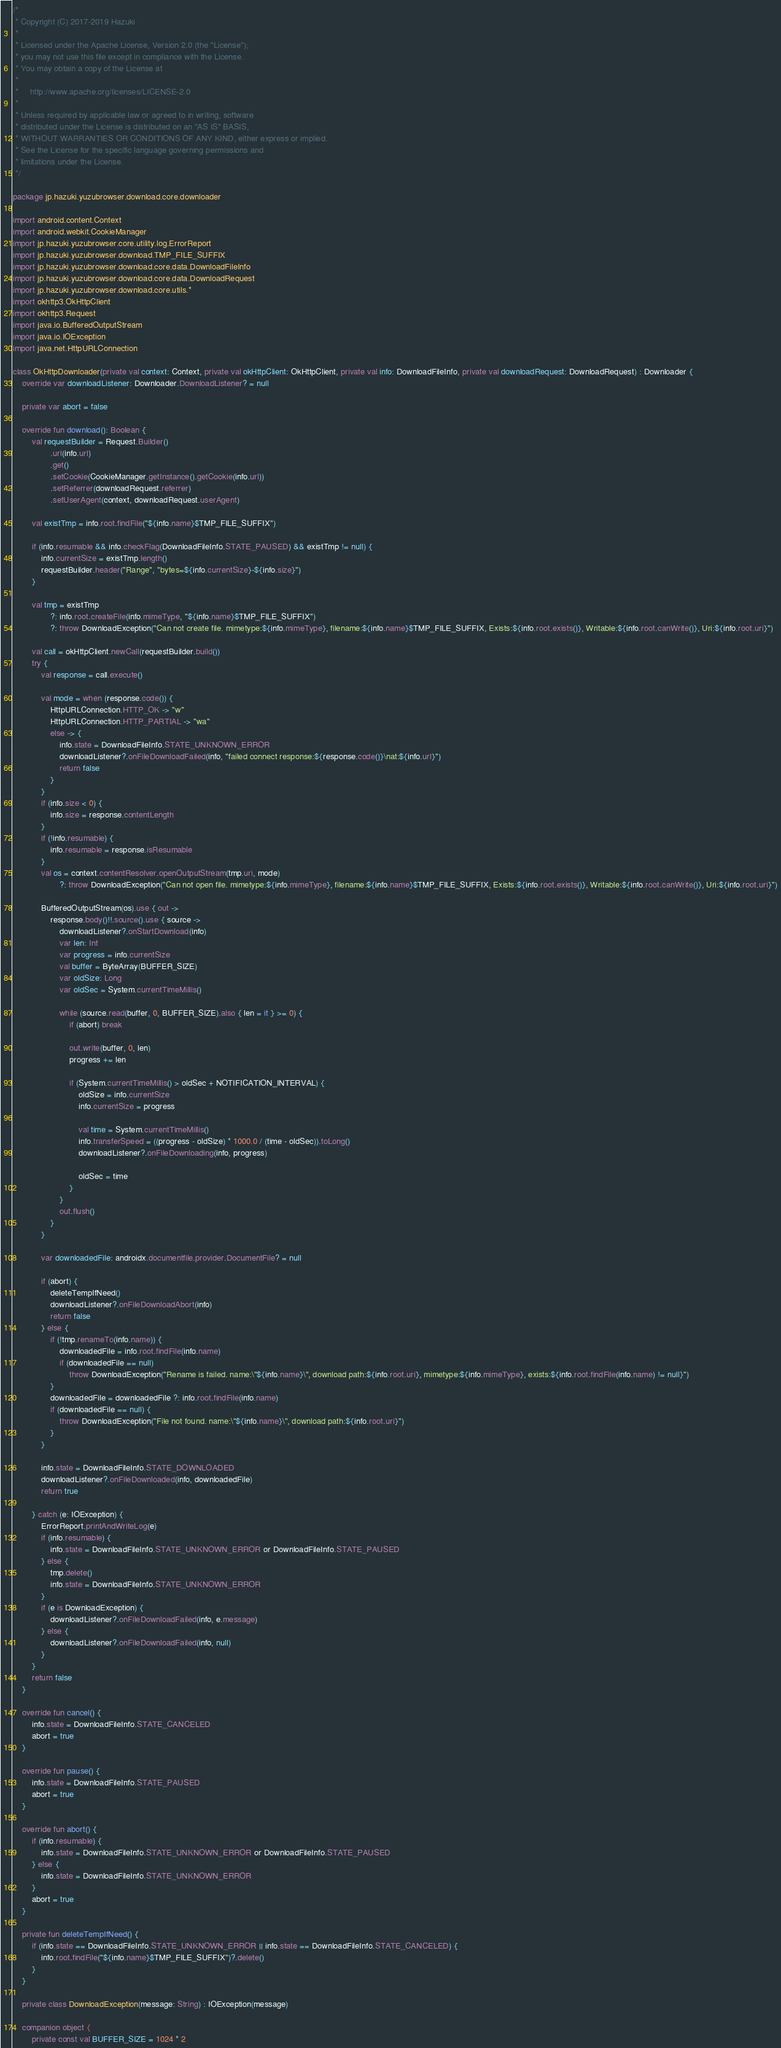Convert code to text. <code><loc_0><loc_0><loc_500><loc_500><_Kotlin_>/*
 * Copyright (C) 2017-2019 Hazuki
 *
 * Licensed under the Apache License, Version 2.0 (the "License");
 * you may not use this file except in compliance with the License.
 * You may obtain a copy of the License at
 *
 *     http://www.apache.org/licenses/LICENSE-2.0
 *
 * Unless required by applicable law or agreed to in writing, software
 * distributed under the License is distributed on an "AS IS" BASIS,
 * WITHOUT WARRANTIES OR CONDITIONS OF ANY KIND, either express or implied.
 * See the License for the specific language governing permissions and
 * limitations under the License.
 */

package jp.hazuki.yuzubrowser.download.core.downloader

import android.content.Context
import android.webkit.CookieManager
import jp.hazuki.yuzubrowser.core.utility.log.ErrorReport
import jp.hazuki.yuzubrowser.download.TMP_FILE_SUFFIX
import jp.hazuki.yuzubrowser.download.core.data.DownloadFileInfo
import jp.hazuki.yuzubrowser.download.core.data.DownloadRequest
import jp.hazuki.yuzubrowser.download.core.utils.*
import okhttp3.OkHttpClient
import okhttp3.Request
import java.io.BufferedOutputStream
import java.io.IOException
import java.net.HttpURLConnection

class OkHttpDownloader(private val context: Context, private val okHttpClient: OkHttpClient, private val info: DownloadFileInfo, private val downloadRequest: DownloadRequest) : Downloader {
    override var downloadListener: Downloader.DownloadListener? = null

    private var abort = false

    override fun download(): Boolean {
        val requestBuilder = Request.Builder()
                .url(info.url)
                .get()
                .setCookie(CookieManager.getInstance().getCookie(info.url))
                .setReferrer(downloadRequest.referrer)
                .setUserAgent(context, downloadRequest.userAgent)

        val existTmp = info.root.findFile("${info.name}$TMP_FILE_SUFFIX")

        if (info.resumable && info.checkFlag(DownloadFileInfo.STATE_PAUSED) && existTmp != null) {
            info.currentSize = existTmp.length()
            requestBuilder.header("Range", "bytes=${info.currentSize}-${info.size}")
        }

        val tmp = existTmp
                ?: info.root.createFile(info.mimeType, "${info.name}$TMP_FILE_SUFFIX")
                ?: throw DownloadException("Can not create file. mimetype:${info.mimeType}, filename:${info.name}$TMP_FILE_SUFFIX, Exists:${info.root.exists()}, Writable:${info.root.canWrite()}, Uri:${info.root.uri}")

        val call = okHttpClient.newCall(requestBuilder.build())
        try {
            val response = call.execute()

            val mode = when (response.code()) {
                HttpURLConnection.HTTP_OK -> "w"
                HttpURLConnection.HTTP_PARTIAL -> "wa"
                else -> {
                    info.state = DownloadFileInfo.STATE_UNKNOWN_ERROR
                    downloadListener?.onFileDownloadFailed(info, "failed connect response:${response.code()}\nat:${info.url}")
                    return false
                }
            }
            if (info.size < 0) {
                info.size = response.contentLength
            }
            if (!info.resumable) {
                info.resumable = response.isResumable
            }
            val os = context.contentResolver.openOutputStream(tmp.uri, mode)
                    ?: throw DownloadException("Can not open file. mimetype:${info.mimeType}, filename:${info.name}$TMP_FILE_SUFFIX, Exists:${info.root.exists()}, Writable:${info.root.canWrite()}, Uri:${info.root.uri}")

            BufferedOutputStream(os).use { out ->
                response.body()!!.source().use { source ->
                    downloadListener?.onStartDownload(info)
                    var len: Int
                    var progress = info.currentSize
                    val buffer = ByteArray(BUFFER_SIZE)
                    var oldSize: Long
                    var oldSec = System.currentTimeMillis()

                    while (source.read(buffer, 0, BUFFER_SIZE).also { len = it } >= 0) {
                        if (abort) break

                        out.write(buffer, 0, len)
                        progress += len

                        if (System.currentTimeMillis() > oldSec + NOTIFICATION_INTERVAL) {
                            oldSize = info.currentSize
                            info.currentSize = progress

                            val time = System.currentTimeMillis()
                            info.transferSpeed = ((progress - oldSize) * 1000.0 / (time - oldSec)).toLong()
                            downloadListener?.onFileDownloading(info, progress)

                            oldSec = time
                        }
                    }
                    out.flush()
                }
            }

            var downloadedFile: androidx.documentfile.provider.DocumentFile? = null

            if (abort) {
                deleteTempIfNeed()
                downloadListener?.onFileDownloadAbort(info)
                return false
            } else {
                if (!tmp.renameTo(info.name)) {
                    downloadedFile = info.root.findFile(info.name)
                    if (downloadedFile == null)
                        throw DownloadException("Rename is failed. name:\"${info.name}\", download path:${info.root.uri}, mimetype:${info.mimeType}, exists:${info.root.findFile(info.name) != null}")
                }
                downloadedFile = downloadedFile ?: info.root.findFile(info.name)
                if (downloadedFile == null) {
                    throw DownloadException("File not found. name:\"${info.name}\", download path:${info.root.uri}")
                }
            }

            info.state = DownloadFileInfo.STATE_DOWNLOADED
            downloadListener?.onFileDownloaded(info, downloadedFile)
            return true

        } catch (e: IOException) {
            ErrorReport.printAndWriteLog(e)
            if (info.resumable) {
                info.state = DownloadFileInfo.STATE_UNKNOWN_ERROR or DownloadFileInfo.STATE_PAUSED
            } else {
                tmp.delete()
                info.state = DownloadFileInfo.STATE_UNKNOWN_ERROR
            }
            if (e is DownloadException) {
                downloadListener?.onFileDownloadFailed(info, e.message)
            } else {
                downloadListener?.onFileDownloadFailed(info, null)
            }
        }
        return false
    }

    override fun cancel() {
        info.state = DownloadFileInfo.STATE_CANCELED
        abort = true
    }

    override fun pause() {
        info.state = DownloadFileInfo.STATE_PAUSED
        abort = true
    }

    override fun abort() {
        if (info.resumable) {
            info.state = DownloadFileInfo.STATE_UNKNOWN_ERROR or DownloadFileInfo.STATE_PAUSED
        } else {
            info.state = DownloadFileInfo.STATE_UNKNOWN_ERROR
        }
        abort = true
    }

    private fun deleteTempIfNeed() {
        if (info.state == DownloadFileInfo.STATE_UNKNOWN_ERROR || info.state == DownloadFileInfo.STATE_CANCELED) {
            info.root.findFile("${info.name}$TMP_FILE_SUFFIX")?.delete()
        }
    }

    private class DownloadException(message: String) : IOException(message)

    companion object {
        private const val BUFFER_SIZE = 1024 * 2</code> 